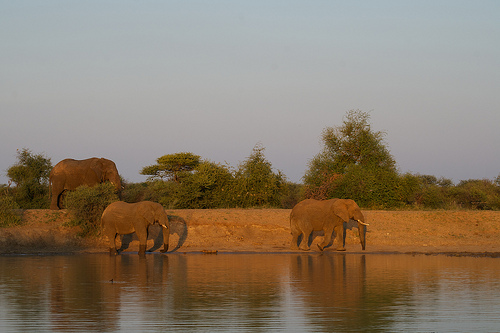How many elephants are shown? There are three elephants in the image, appearing serene as they wander along the water's edge in the warm, golden light of either sunrise or sunset. 